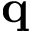<formula> <loc_0><loc_0><loc_500><loc_500>q</formula> 